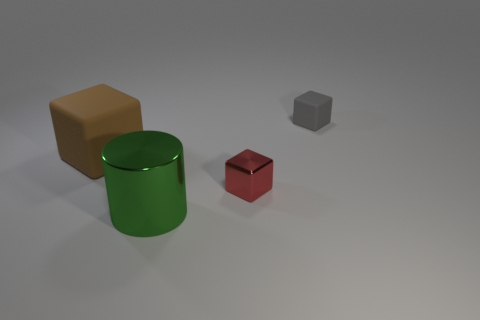Is there any indication of the size of the space where these objects are placed? The image provides limited context regarding the size of the space, but the shadows cast by the objects imply that there's a single light source and the space is likely indoors given the neutral background and flat surface. Could the space be part of a studio setup? Yes, the controlled lighting and the simplicity of the setting suggest that this could very well be a studio setup designed for photographing objects without distraction. 